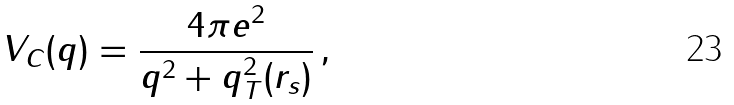Convert formula to latex. <formula><loc_0><loc_0><loc_500><loc_500>V _ { C } ( q ) = \frac { 4 \pi e ^ { 2 } } { q ^ { 2 } + q _ { T } ^ { 2 } ( r _ { s } ) } \, ,</formula> 